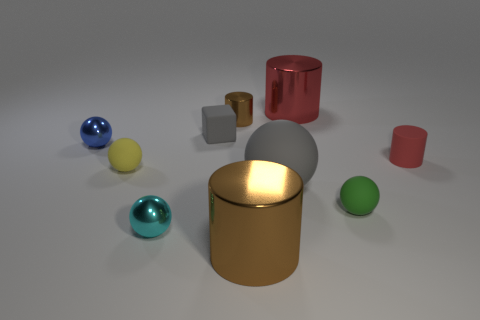Subtract all blue spheres. How many spheres are left? 4 Subtract all gray rubber balls. How many balls are left? 4 Subtract all blue cylinders. Subtract all cyan blocks. How many cylinders are left? 4 Subtract all blocks. How many objects are left? 9 Subtract all tiny red cylinders. Subtract all tiny gray matte cubes. How many objects are left? 8 Add 8 big shiny cylinders. How many big shiny cylinders are left? 10 Add 6 tiny purple metal blocks. How many tiny purple metal blocks exist? 6 Subtract 0 yellow blocks. How many objects are left? 10 